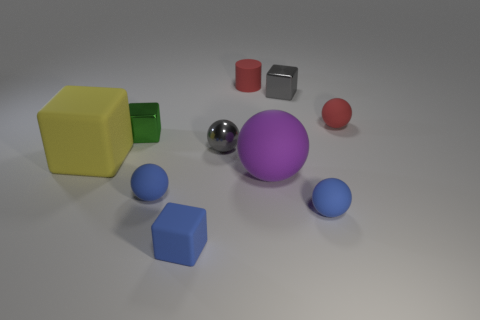Subtract all red spheres. How many spheres are left? 4 Subtract all gray metal balls. How many balls are left? 4 Subtract all green balls. Subtract all purple blocks. How many balls are left? 5 Subtract all cylinders. How many objects are left? 9 Add 4 blue things. How many blue things are left? 7 Add 4 big things. How many big things exist? 6 Subtract 0 purple cubes. How many objects are left? 10 Subtract all green shiny cubes. Subtract all tiny yellow blocks. How many objects are left? 9 